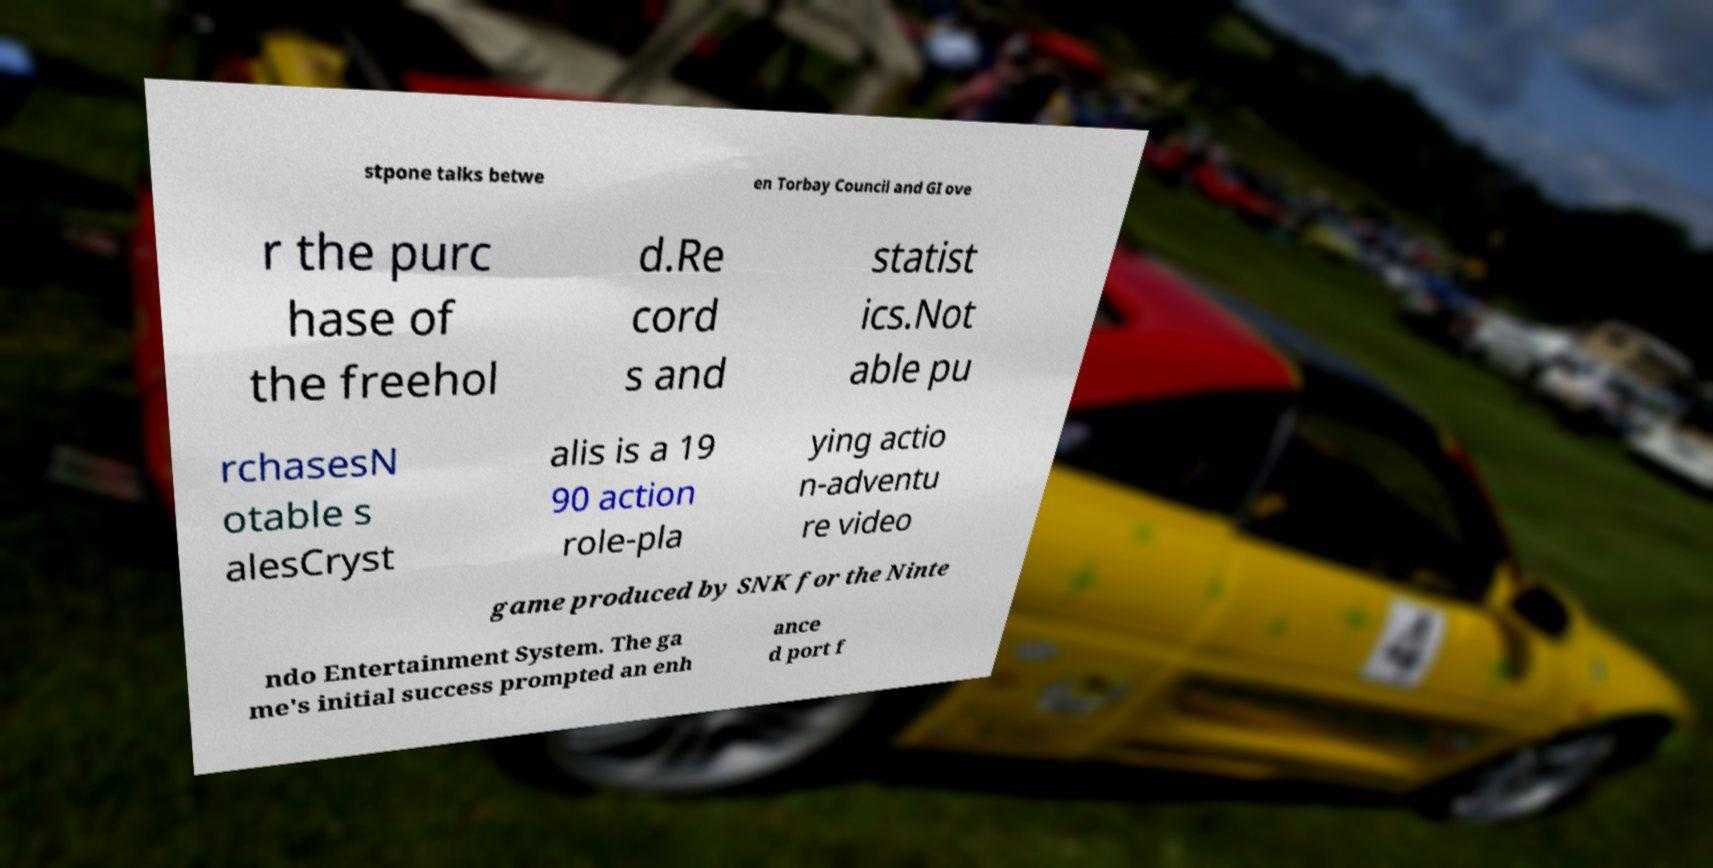Please read and relay the text visible in this image. What does it say? stpone talks betwe en Torbay Council and GI ove r the purc hase of the freehol d.Re cord s and statist ics.Not able pu rchasesN otable s alesCryst alis is a 19 90 action role-pla ying actio n-adventu re video game produced by SNK for the Ninte ndo Entertainment System. The ga me's initial success prompted an enh ance d port f 